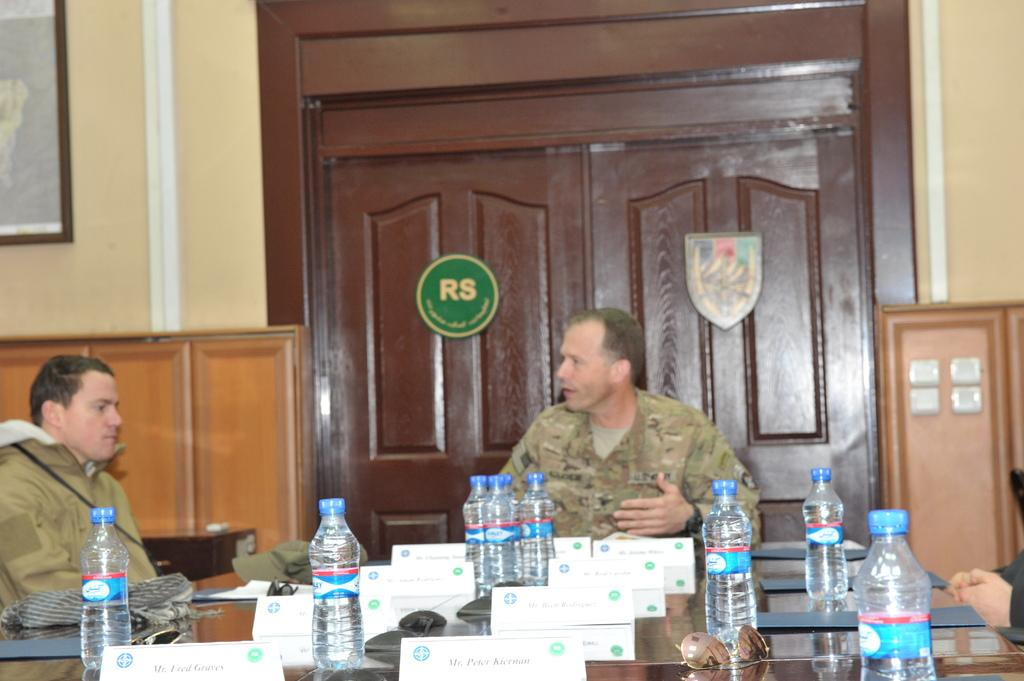Provide a one-sentence caption for the provided image. Soldier in a corporate board meeting room which features brown doors that have RS written on them. 